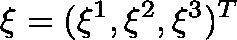<formula> <loc_0><loc_0><loc_500><loc_500>\xi = ( \xi ^ { 1 } , \xi ^ { 2 } , \xi ^ { 3 } ) ^ { T }</formula> 